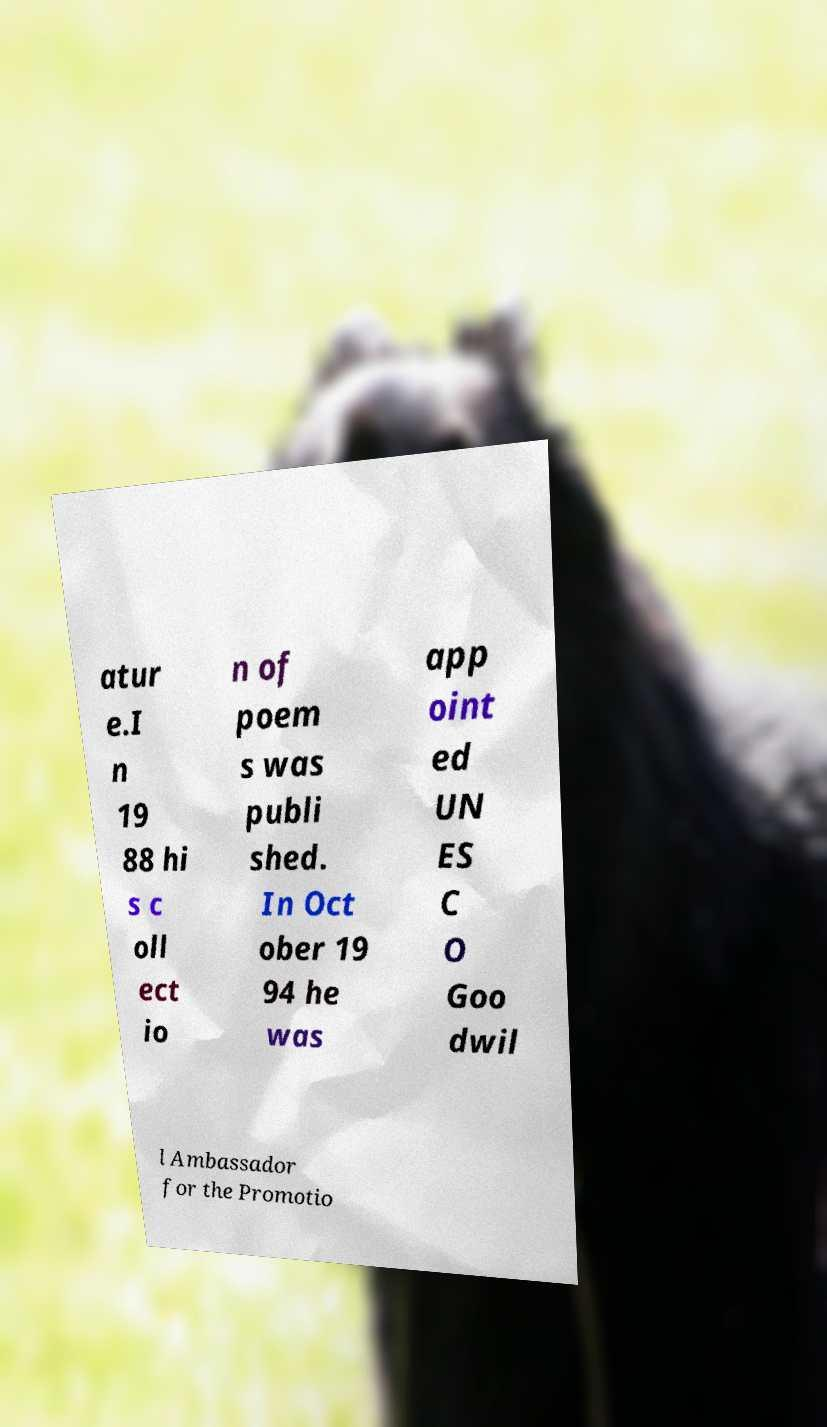What messages or text are displayed in this image? I need them in a readable, typed format. atur e.I n 19 88 hi s c oll ect io n of poem s was publi shed. In Oct ober 19 94 he was app oint ed UN ES C O Goo dwil l Ambassador for the Promotio 